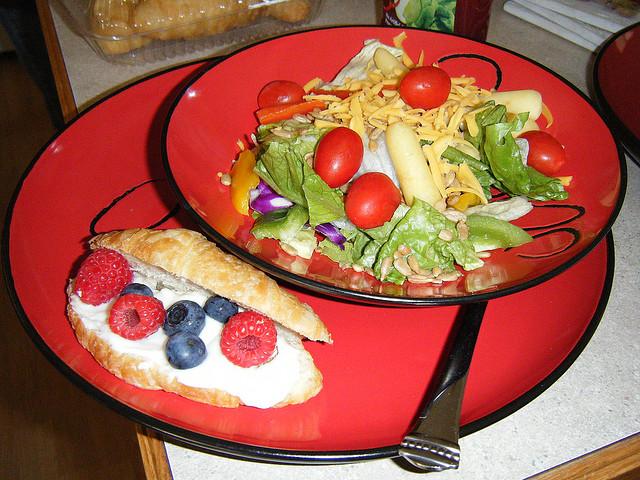What is on the salad?
Answer briefly. Tomatoes. What are the red things in the salad?
Short answer required. Tomatoes. What is on the plate?
Keep it brief. Salad. Does this look like an American dish?
Quick response, please. Yes. 